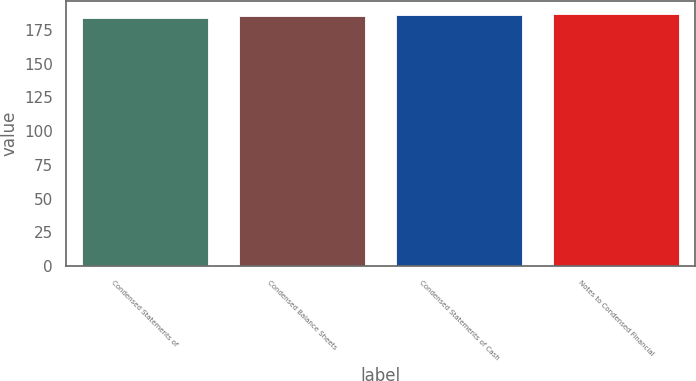<chart> <loc_0><loc_0><loc_500><loc_500><bar_chart><fcel>Condensed Statements of<fcel>Condensed Balance Sheets<fcel>Condensed Statements of Cash<fcel>Notes to Condensed Financial<nl><fcel>184<fcel>185<fcel>186<fcel>187<nl></chart> 